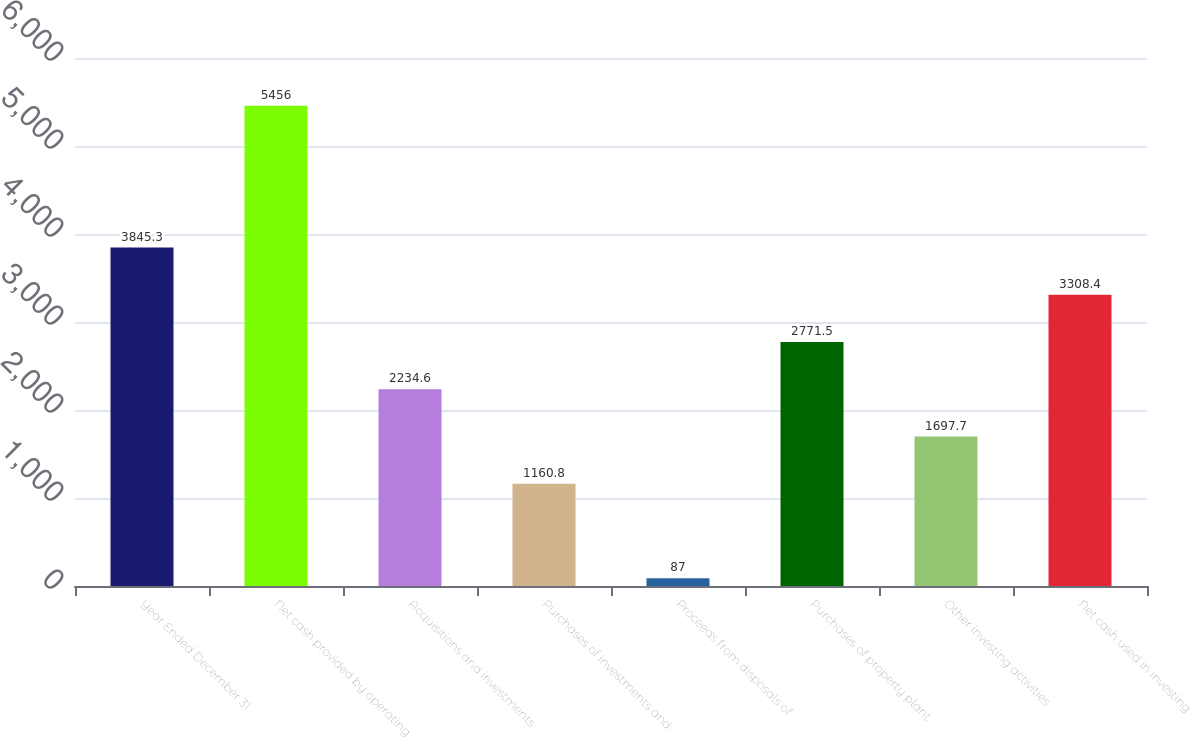Convert chart to OTSL. <chart><loc_0><loc_0><loc_500><loc_500><bar_chart><fcel>Year Ended December 31<fcel>Net cash provided by operating<fcel>Acquisitions and investments<fcel>Purchases of investments and<fcel>Proceeds from disposals of<fcel>Purchases of property plant<fcel>Other investing activities<fcel>Net cash used in investing<nl><fcel>3845.3<fcel>5456<fcel>2234.6<fcel>1160.8<fcel>87<fcel>2771.5<fcel>1697.7<fcel>3308.4<nl></chart> 